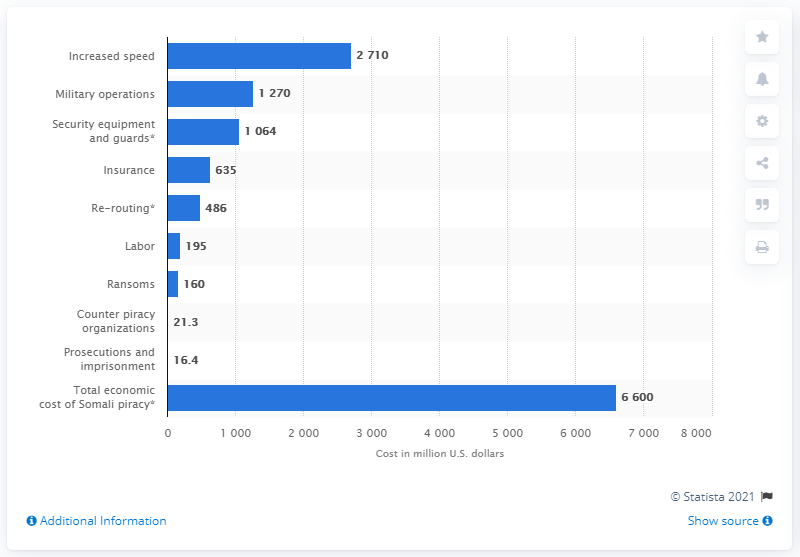List a handful of essential elements in this visual. In 2011, approximately $635 was spent on insurance payments. 